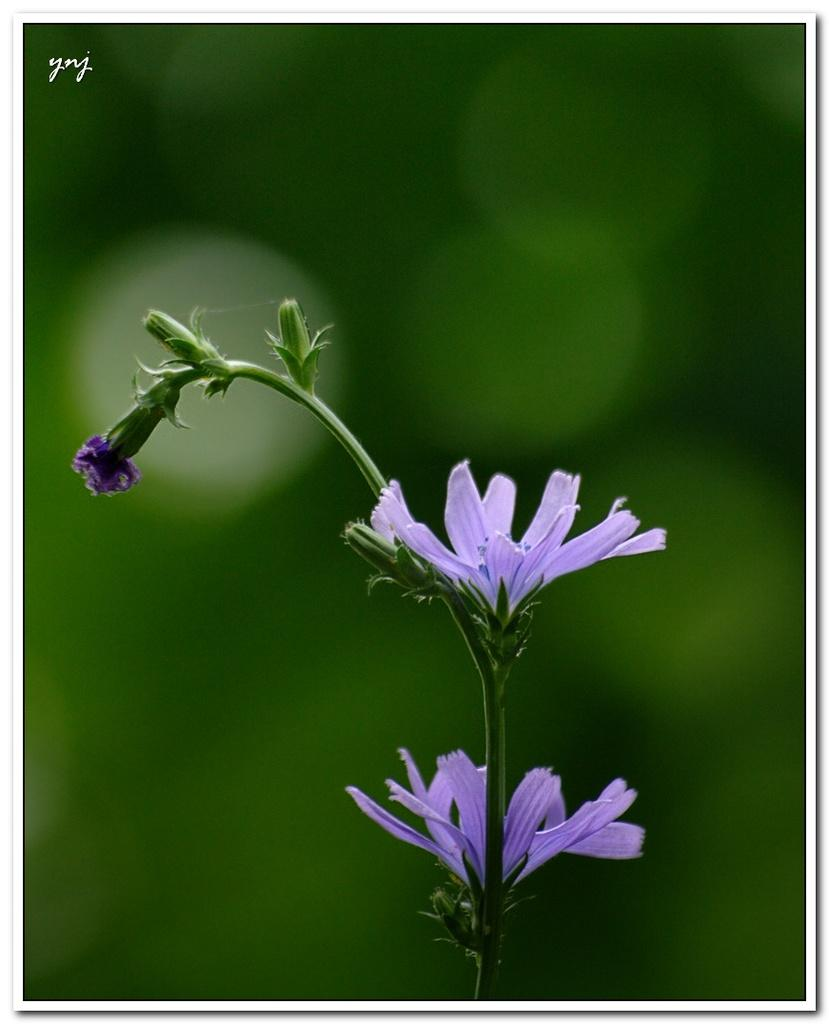What type of plant is featured in the image? The image features a plant with flowers. What color are the flowers on the plant? The flowers on the plant are purple. Can you describe the background of the image? The background of the image is blurred. What type of chess piece can be seen in the image? There is no chess piece present in the image; it features a plant with purple flowers. What type of humor is depicted in the image? There is no humor depicted in the image; it features a plant with purple flowers and a blurred background. 